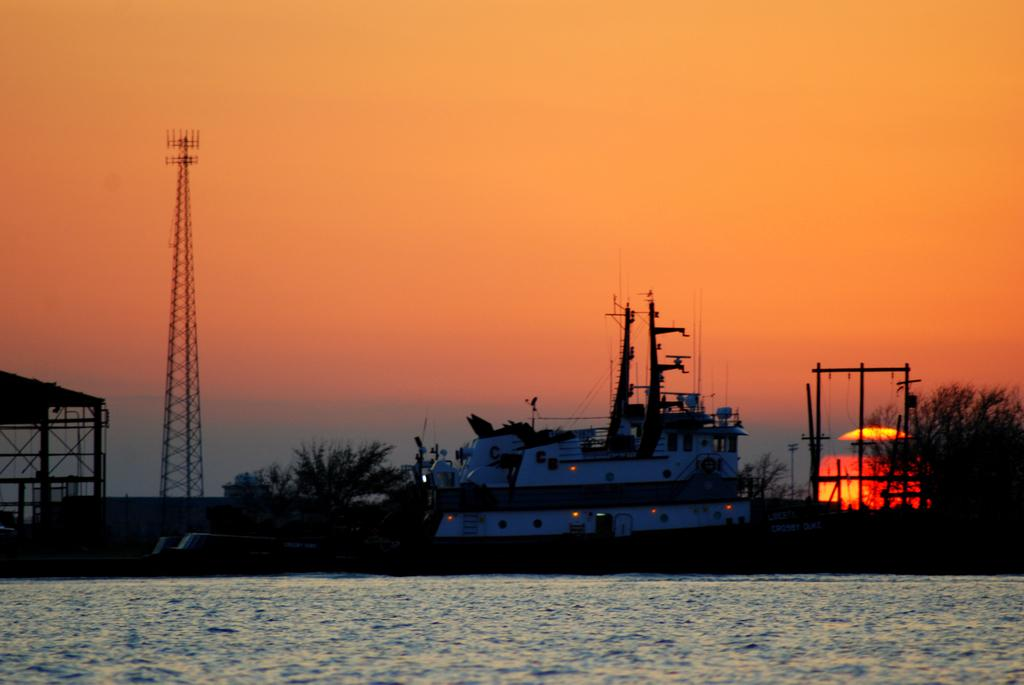What is the main subject in the center of the image? There is water in the center of the image. What can be seen in the background of the image? There is a ship, trees, and a tower in the background of the image. Where is the shed located in the image? The shed is on the left side of the image. What type of story is being told by the train in the image? There is no train present in the image, so no story can be told by a train. 